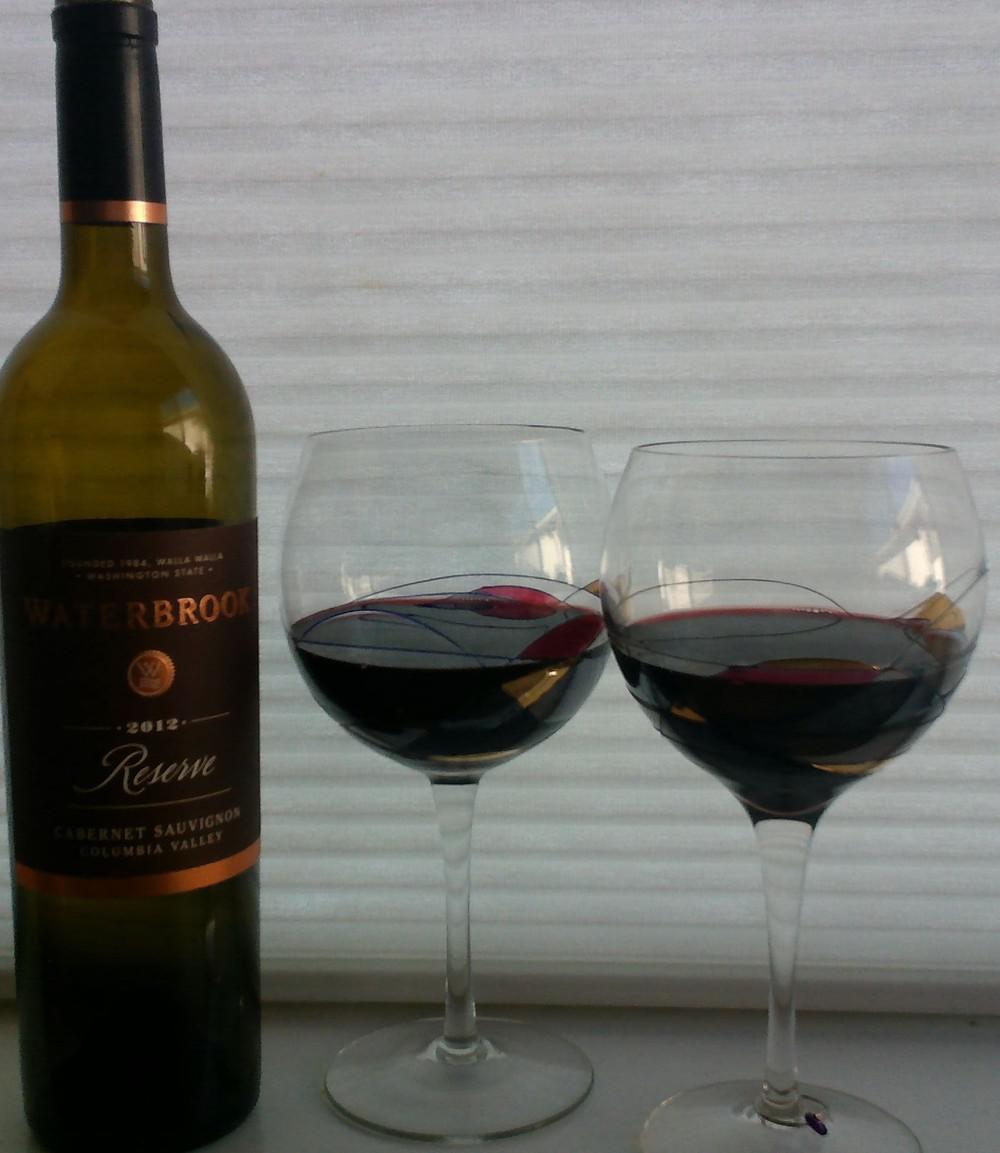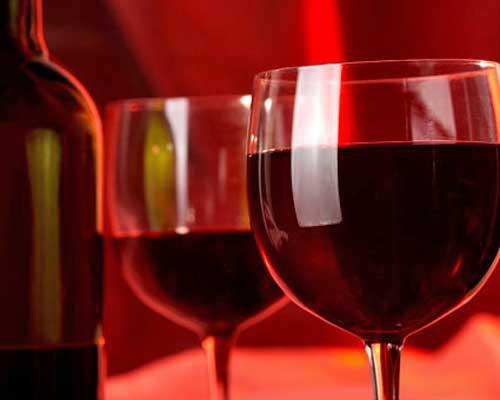The first image is the image on the left, the second image is the image on the right. For the images shown, is this caption "A hearth fire is visible in the background behind two glasses of dark red wine." true? Answer yes or no. No. The first image is the image on the left, the second image is the image on the right. Evaluate the accuracy of this statement regarding the images: "A wine bottle is near two wine glasses in at least one of the images.". Is it true? Answer yes or no. Yes. 